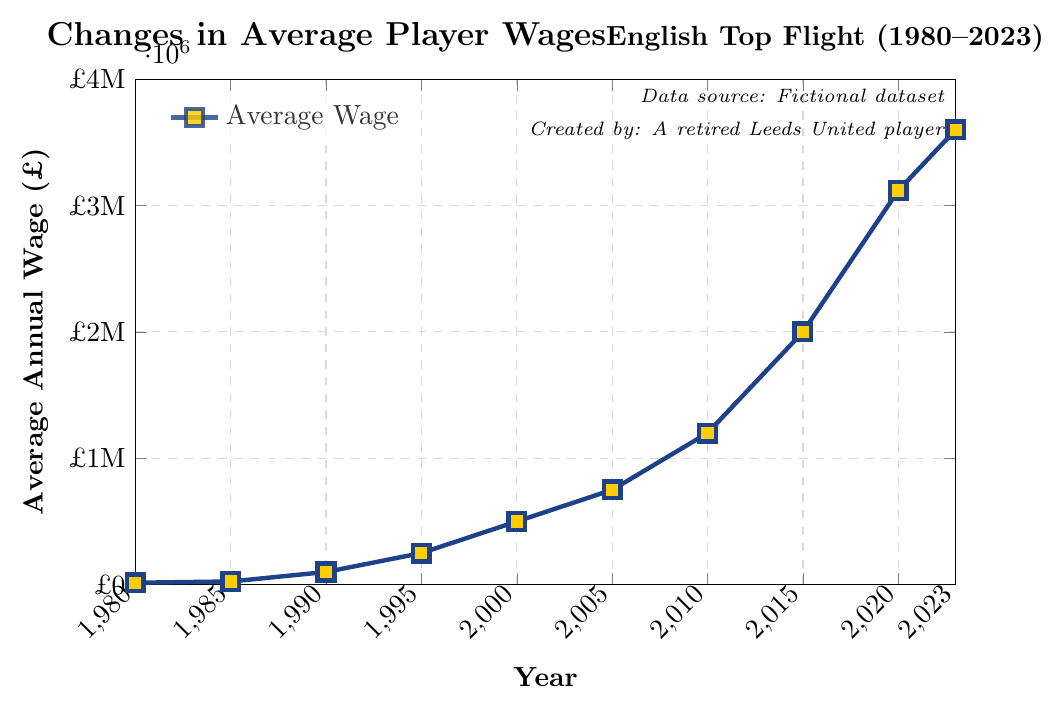What's the general trend of player wages between 1980 and 2023? The line chart shows a steady increase in average player wages from 1980 (£15,000) to 2023 (£3,600,000). This indicates an overall upward trend.
Answer: Steady increase During which period did the average annual wage see the most significant increase? The chart shows the most significant increase between 1990 (£100,000) and 2020 (£3,120,000), particularly sharp between 2015 (£2,000,000) and 2020 (£3,120,000).
Answer: 2015 to 2020 What was the average annual wage in 1990 and how does it compare to that in 2000? In 1990, the average annual wage was £100,000, and in 2000 it was £500,000. The wage in 2000 was £400,000 higher than in 1990.
Answer: 2000 was £400,000 higher How much did the average annual wage increase from 1985 to 1995? The average annual wage in 1985 was £25,000 and in 1995 it was £250,000. The increase is £250,000 - £25,000 = £225,000.
Answer: £225,000 What is the difference in wages between 2005 and 2010? In 2005, the wage was £750,000 and in 2010, it was £1,200,000. The difference is £1,200,000 - £750,000 = £450,000.
Answer: £450,000 Which year showed the smallest increase compared to its previous data point? The smallest increase is between 1980 (£15,000) and 1985 (£25,000), which is £10,000.
Answer: 1985 How does the wage in 1985 compare to the wage in 2023? The wage in 1985 was £25,000, while in 2023 it was £3,600,000. The wage in 2023 is significantly higher.
Answer: Wage in 2023 is significantly higher What is the average annual wage in 2015, and what are the subsequent increases until 2023? In 2015, the wage was £2,000,000. The increase to 2020 was £1,120,000 (£3,120,000 - £2,000,000) and from 2020 to 2023 it was £480,000 (£3,600,000 - £3,120,000).
Answer: £2,000,000; £1,120,000; £480,000 By how much did the average wage increase from 1980 to 2023? The average wage in 1980 was £15,000 and in 2023 it was £3,600,000. The increase is £3,600,000 - £15,000 = £3,585,000.
Answer: £3,585,000 